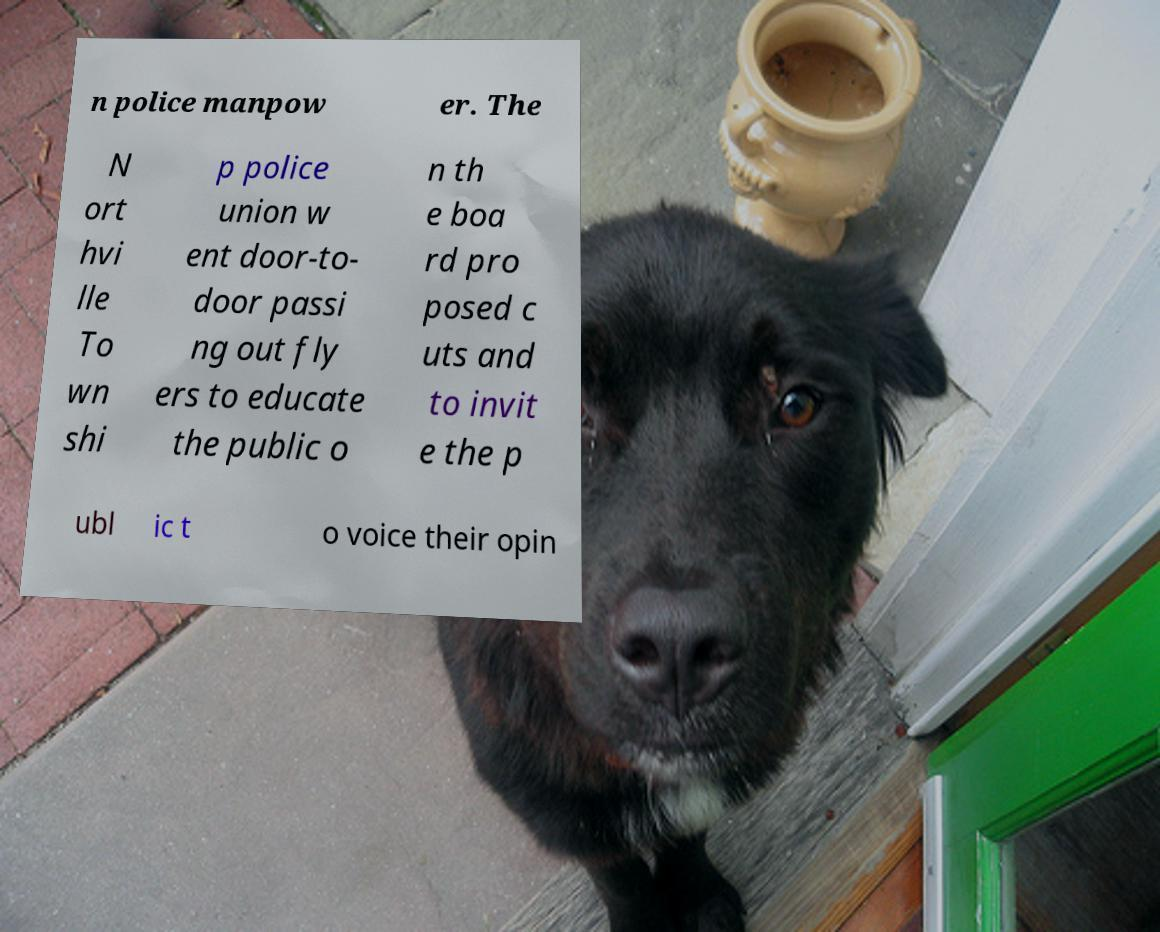I need the written content from this picture converted into text. Can you do that? n police manpow er. The N ort hvi lle To wn shi p police union w ent door-to- door passi ng out fly ers to educate the public o n th e boa rd pro posed c uts and to invit e the p ubl ic t o voice their opin 